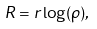<formula> <loc_0><loc_0><loc_500><loc_500>R & = r \log ( \rho ) ,</formula> 